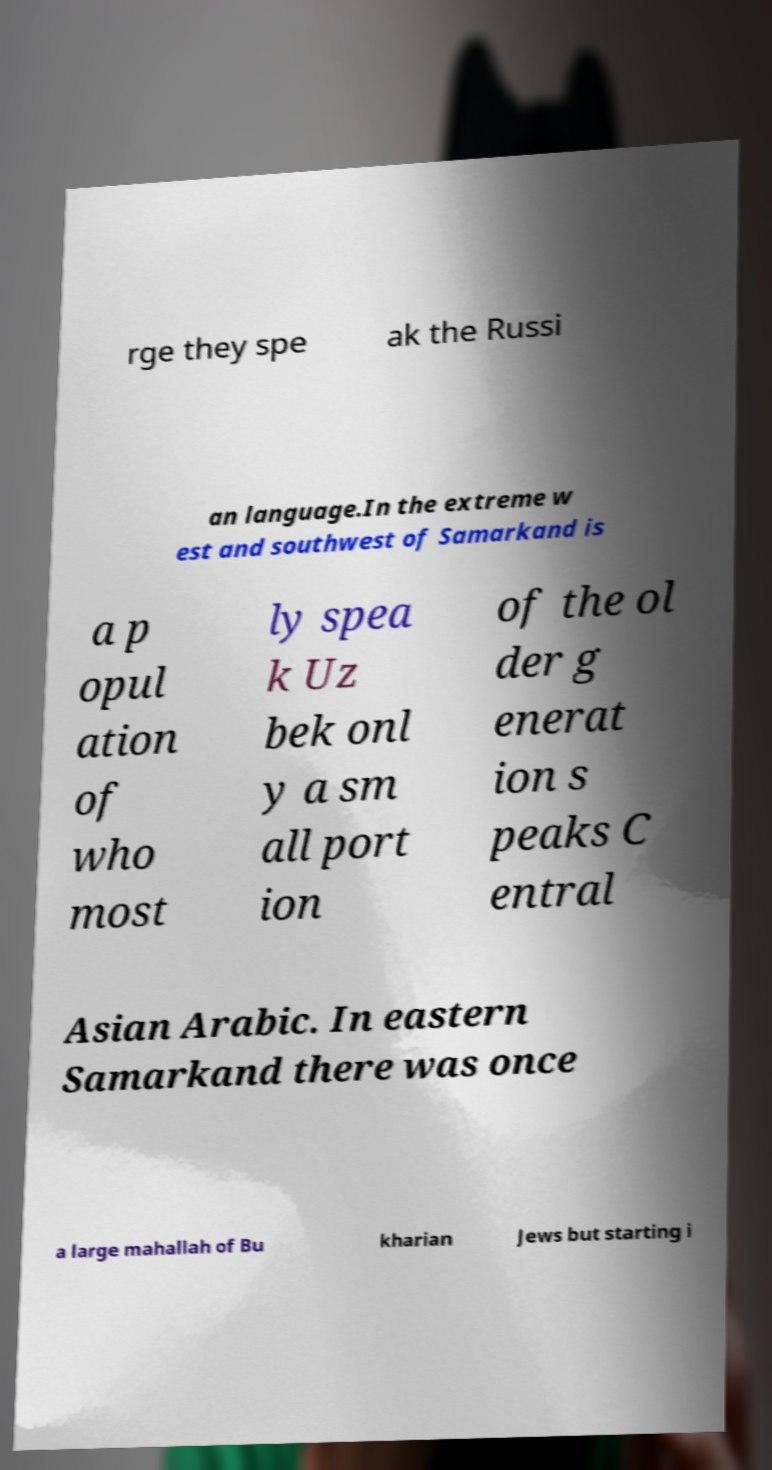Can you accurately transcribe the text from the provided image for me? rge they spe ak the Russi an language.In the extreme w est and southwest of Samarkand is a p opul ation of who most ly spea k Uz bek onl y a sm all port ion of the ol der g enerat ion s peaks C entral Asian Arabic. In eastern Samarkand there was once a large mahallah of Bu kharian Jews but starting i 